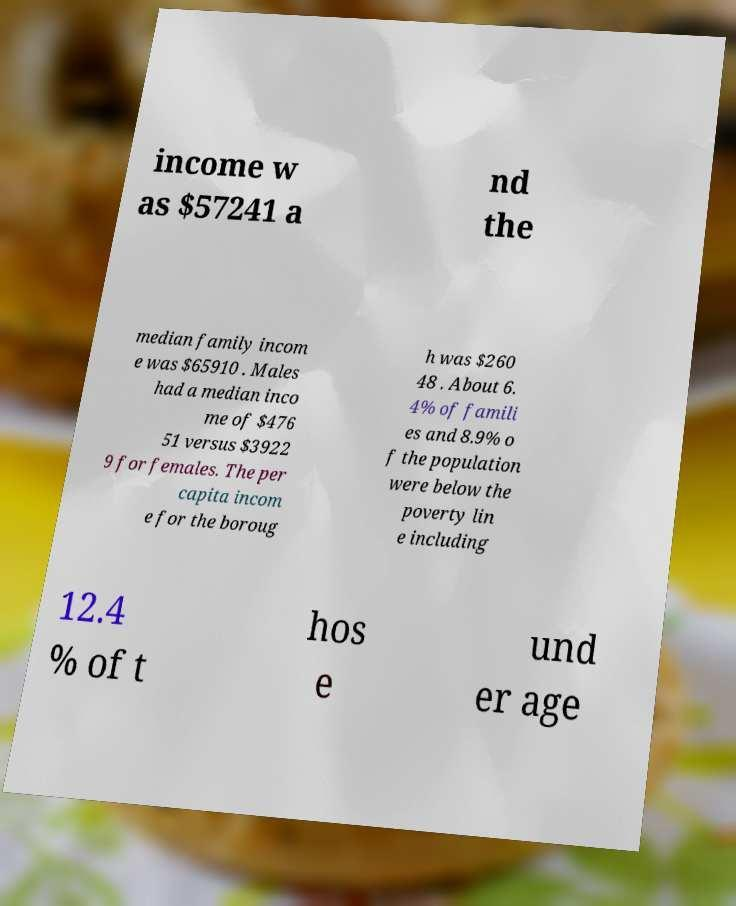There's text embedded in this image that I need extracted. Can you transcribe it verbatim? income w as $57241 a nd the median family incom e was $65910 . Males had a median inco me of $476 51 versus $3922 9 for females. The per capita incom e for the boroug h was $260 48 . About 6. 4% of famili es and 8.9% o f the population were below the poverty lin e including 12.4 % of t hos e und er age 